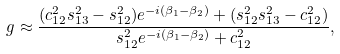Convert formula to latex. <formula><loc_0><loc_0><loc_500><loc_500>g \approx \frac { ( c _ { 1 2 } ^ { 2 } s _ { 1 3 } ^ { 2 } - s _ { 1 2 } ^ { 2 } ) e ^ { - i ( \beta _ { 1 } - \beta _ { 2 } ) } + ( s _ { 1 2 } ^ { 2 } s _ { 1 3 } ^ { 2 } - c _ { 1 2 } ^ { 2 } ) } { s _ { 1 2 } ^ { 2 } e ^ { - i ( \beta _ { 1 } - \beta _ { 2 } ) } + c _ { 1 2 } ^ { 2 } } ,</formula> 